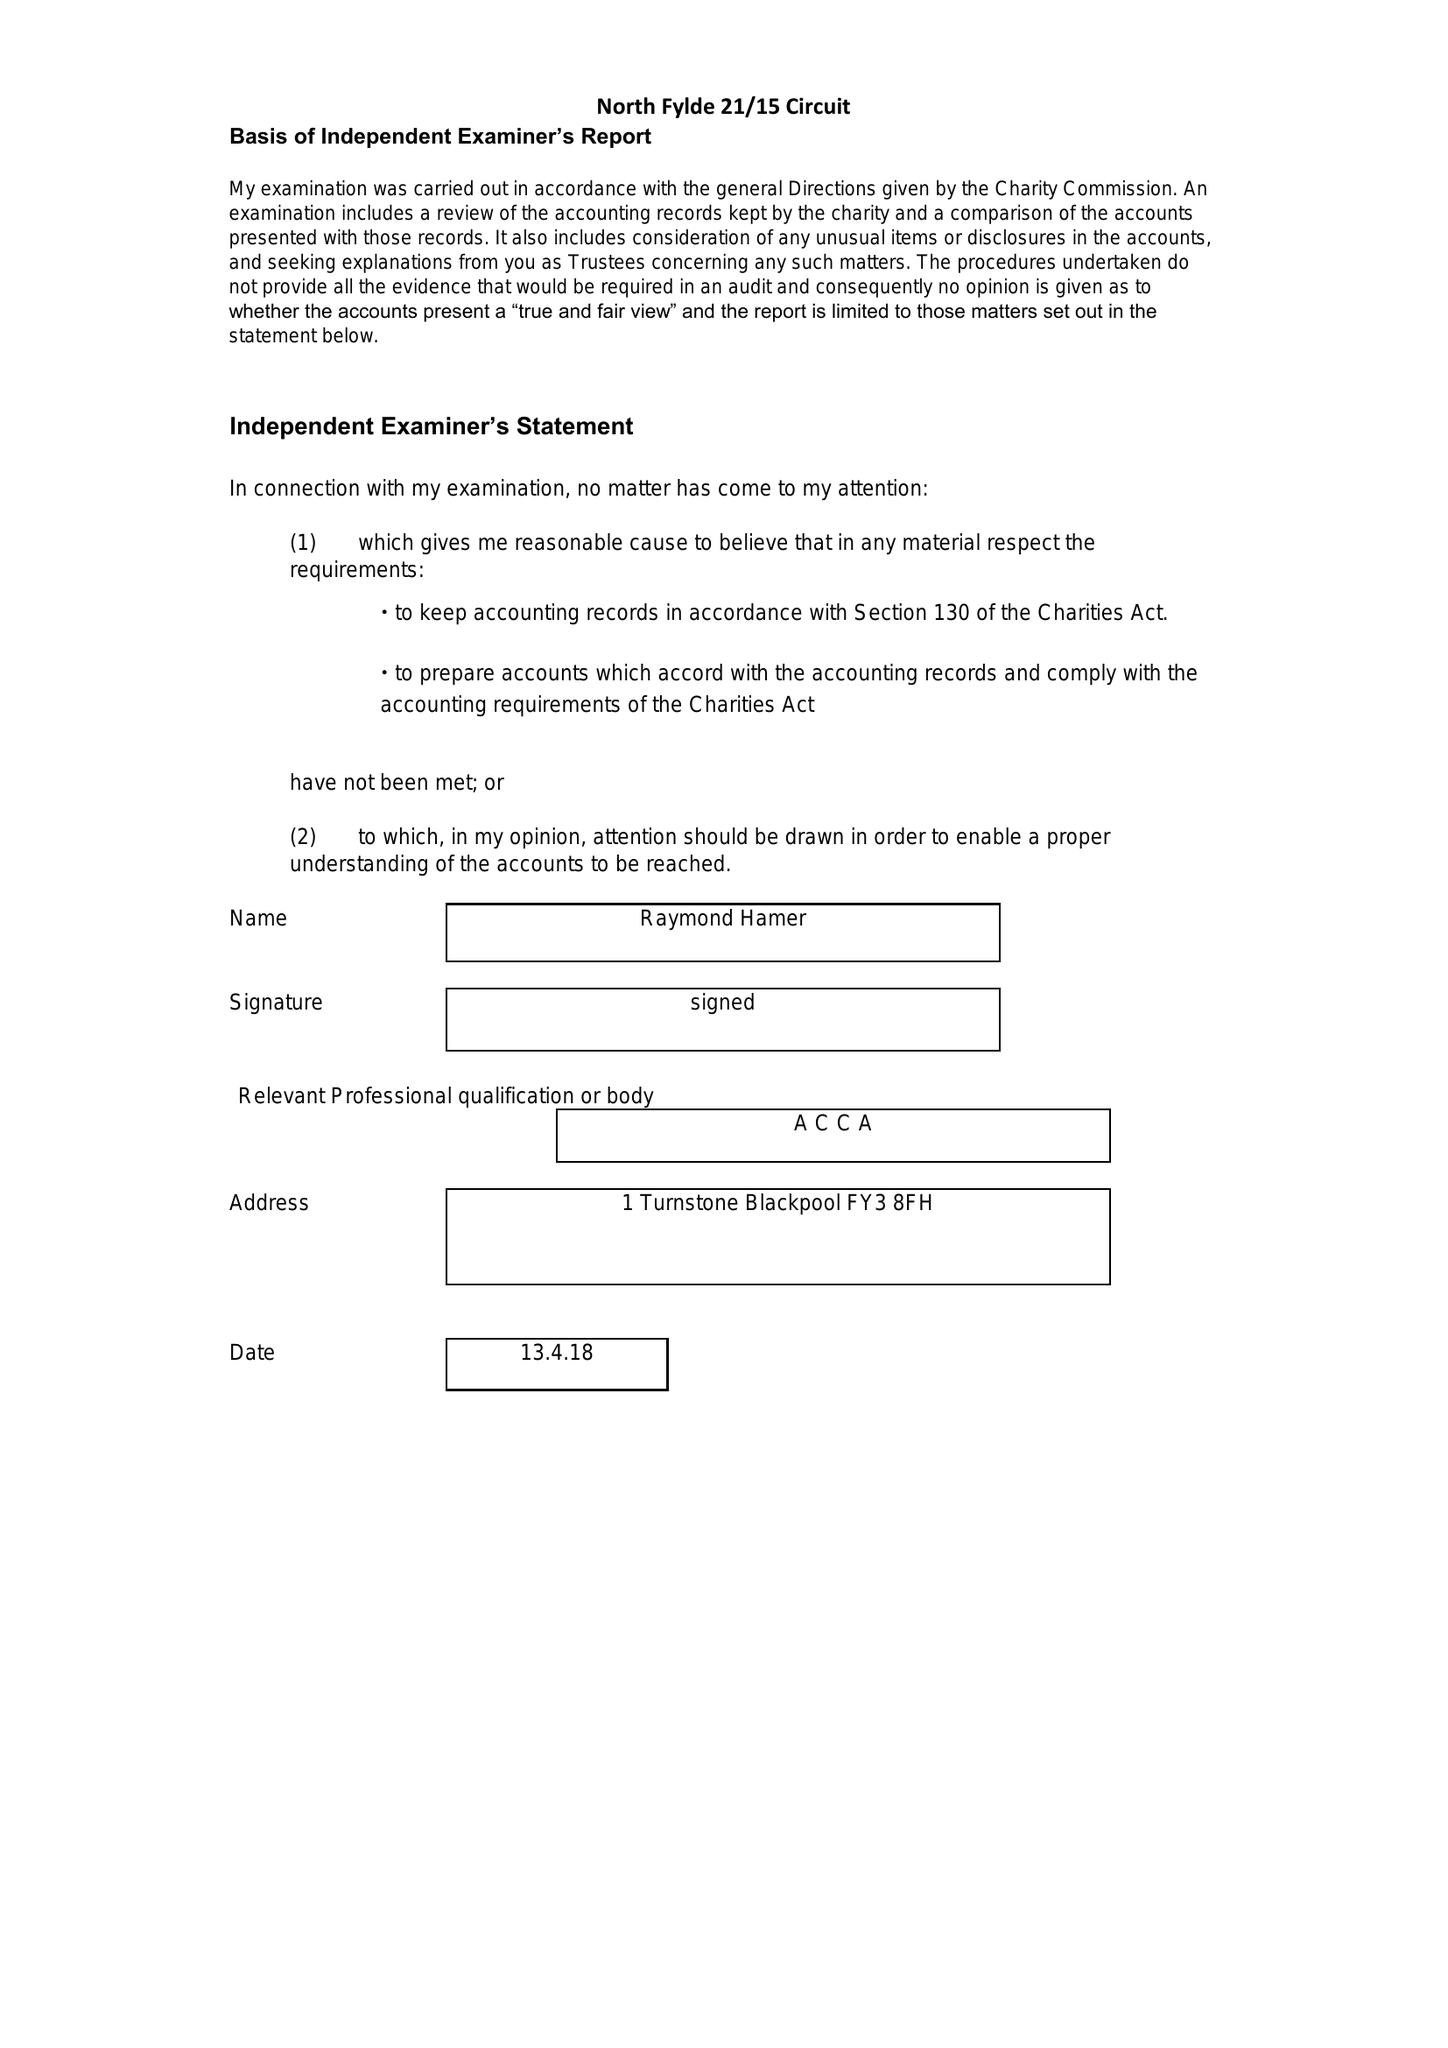What is the value for the address__post_town?
Answer the question using a single word or phrase. POULTON-LE-FYLDE 